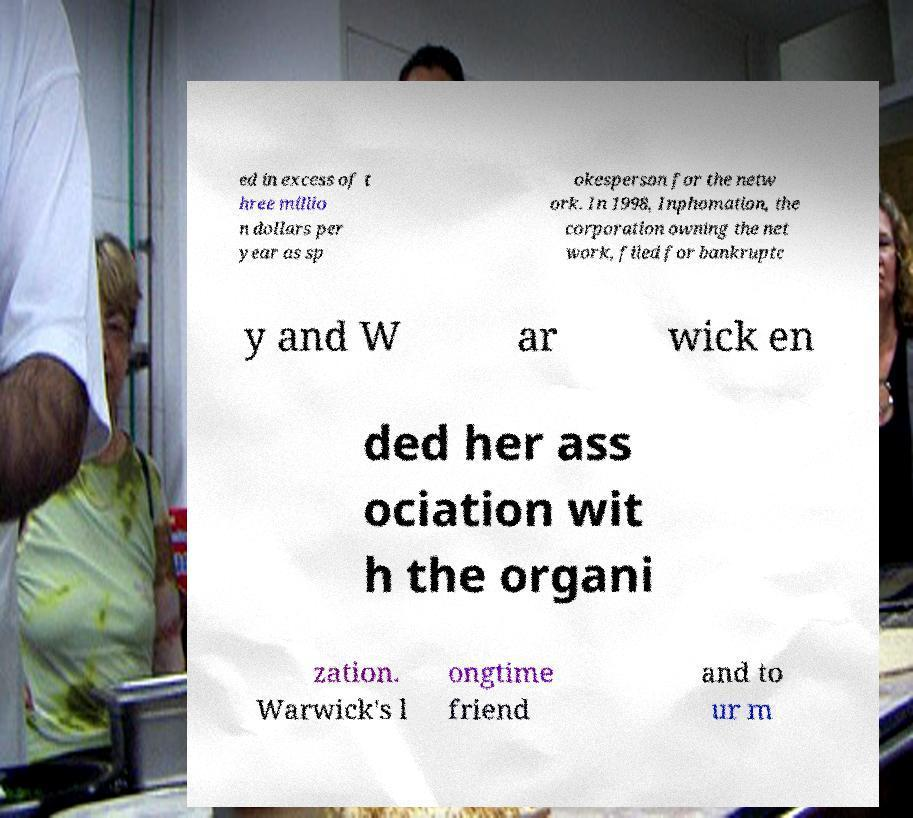Could you extract and type out the text from this image? ed in excess of t hree millio n dollars per year as sp okesperson for the netw ork. In 1998, Inphomation, the corporation owning the net work, filed for bankruptc y and W ar wick en ded her ass ociation wit h the organi zation. Warwick's l ongtime friend and to ur m 